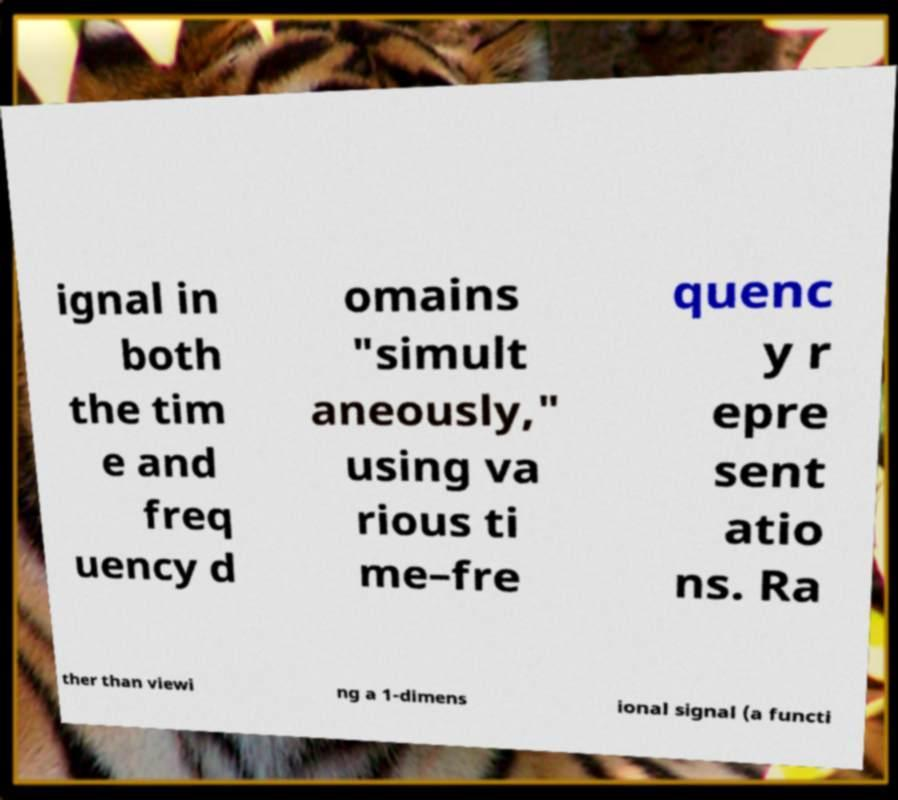Can you read and provide the text displayed in the image?This photo seems to have some interesting text. Can you extract and type it out for me? ignal in both the tim e and freq uency d omains "simult aneously," using va rious ti me–fre quenc y r epre sent atio ns. Ra ther than viewi ng a 1-dimens ional signal (a functi 